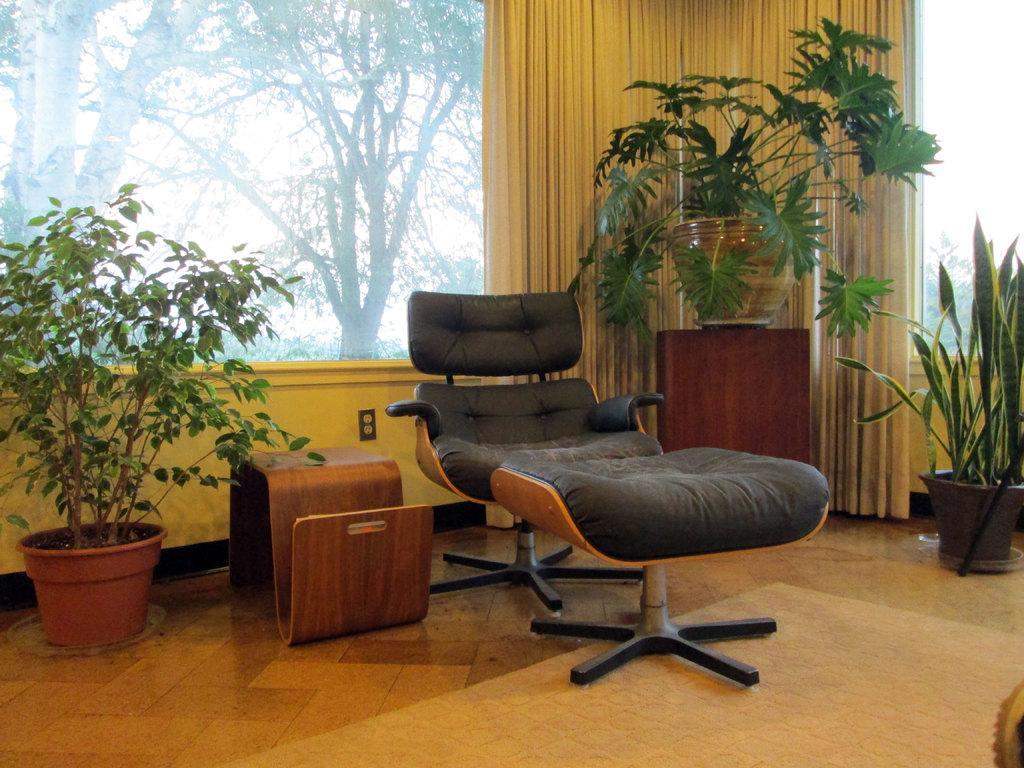Describe this image in one or two sentences. Here we can see a chair in the center and there are plants placed here and there in the room, there is a table beside the chair and about that we can see a window and a curtain through which we can see trees 